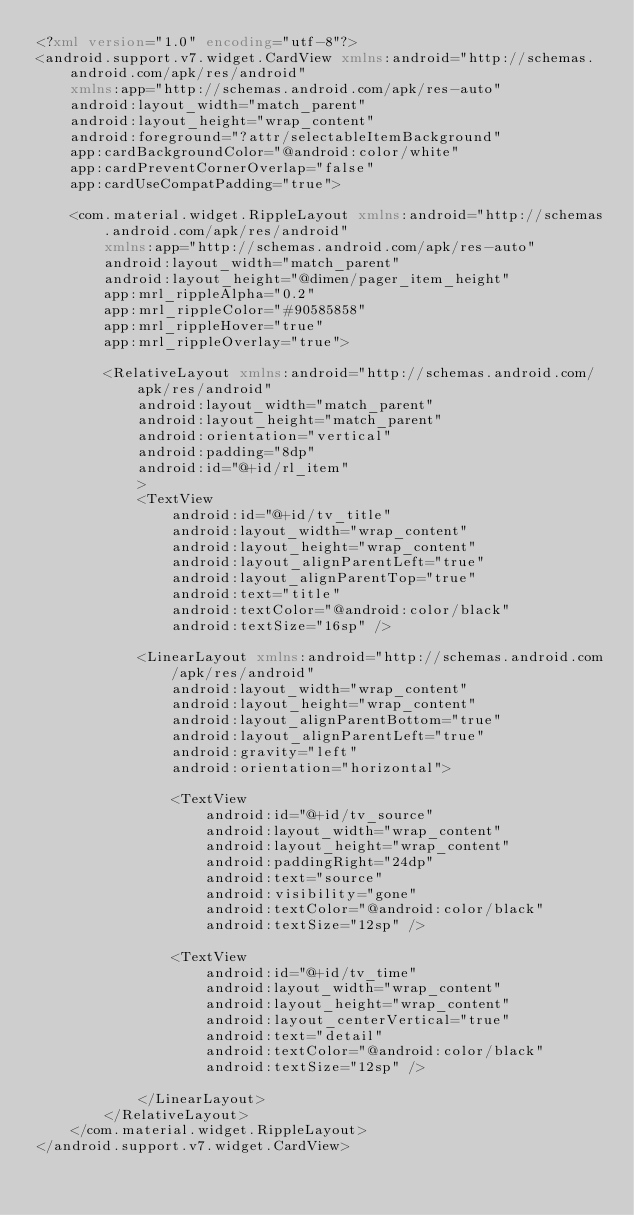<code> <loc_0><loc_0><loc_500><loc_500><_XML_><?xml version="1.0" encoding="utf-8"?>
<android.support.v7.widget.CardView xmlns:android="http://schemas.android.com/apk/res/android"
    xmlns:app="http://schemas.android.com/apk/res-auto"
    android:layout_width="match_parent"
    android:layout_height="wrap_content"
    android:foreground="?attr/selectableItemBackground"
    app:cardBackgroundColor="@android:color/white"
    app:cardPreventCornerOverlap="false"
    app:cardUseCompatPadding="true">

    <com.material.widget.RippleLayout xmlns:android="http://schemas.android.com/apk/res/android"
        xmlns:app="http://schemas.android.com/apk/res-auto"
        android:layout_width="match_parent"
        android:layout_height="@dimen/pager_item_height"
        app:mrl_rippleAlpha="0.2"
        app:mrl_rippleColor="#90585858"
        app:mrl_rippleHover="true"
        app:mrl_rippleOverlay="true">

        <RelativeLayout xmlns:android="http://schemas.android.com/apk/res/android"
            android:layout_width="match_parent"
            android:layout_height="match_parent"
            android:orientation="vertical"
            android:padding="8dp"
            android:id="@+id/rl_item"
            >
            <TextView
                android:id="@+id/tv_title"
                android:layout_width="wrap_content"
                android:layout_height="wrap_content"
                android:layout_alignParentLeft="true"
                android:layout_alignParentTop="true"
                android:text="title"
                android:textColor="@android:color/black"
                android:textSize="16sp" />

            <LinearLayout xmlns:android="http://schemas.android.com/apk/res/android"
                android:layout_width="wrap_content"
                android:layout_height="wrap_content"
                android:layout_alignParentBottom="true"
                android:layout_alignParentLeft="true"
                android:gravity="left"
                android:orientation="horizontal">

                <TextView
                    android:id="@+id/tv_source"
                    android:layout_width="wrap_content"
                    android:layout_height="wrap_content"
                    android:paddingRight="24dp"
                    android:text="source"
                    android:visibility="gone"
                    android:textColor="@android:color/black"
                    android:textSize="12sp" />

                <TextView
                    android:id="@+id/tv_time"
                    android:layout_width="wrap_content"
                    android:layout_height="wrap_content"
                    android:layout_centerVertical="true"
                    android:text="detail"
                    android:textColor="@android:color/black"
                    android:textSize="12sp" />

            </LinearLayout>
        </RelativeLayout>
    </com.material.widget.RippleLayout>
</android.support.v7.widget.CardView></code> 